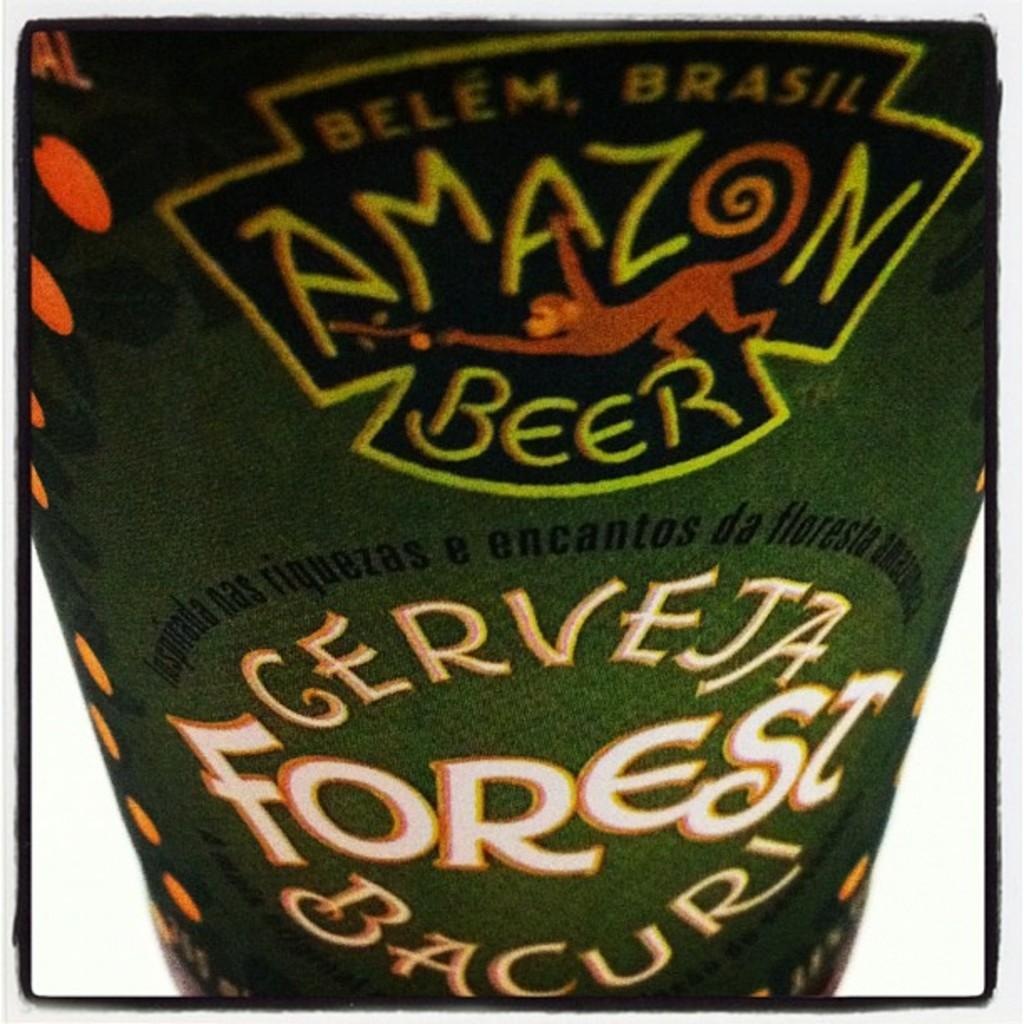What is the main subject of the image? The main subject of the image is a beverage. Can you describe the beverage in the image? Unfortunately, the provided facts do not give any details about the beverage. However, we can confirm that there is a beverage in the center of the image. What color is the wing of the grandfather in the image? There is no grandfather or wing present in the image. The image only features a beverage. 